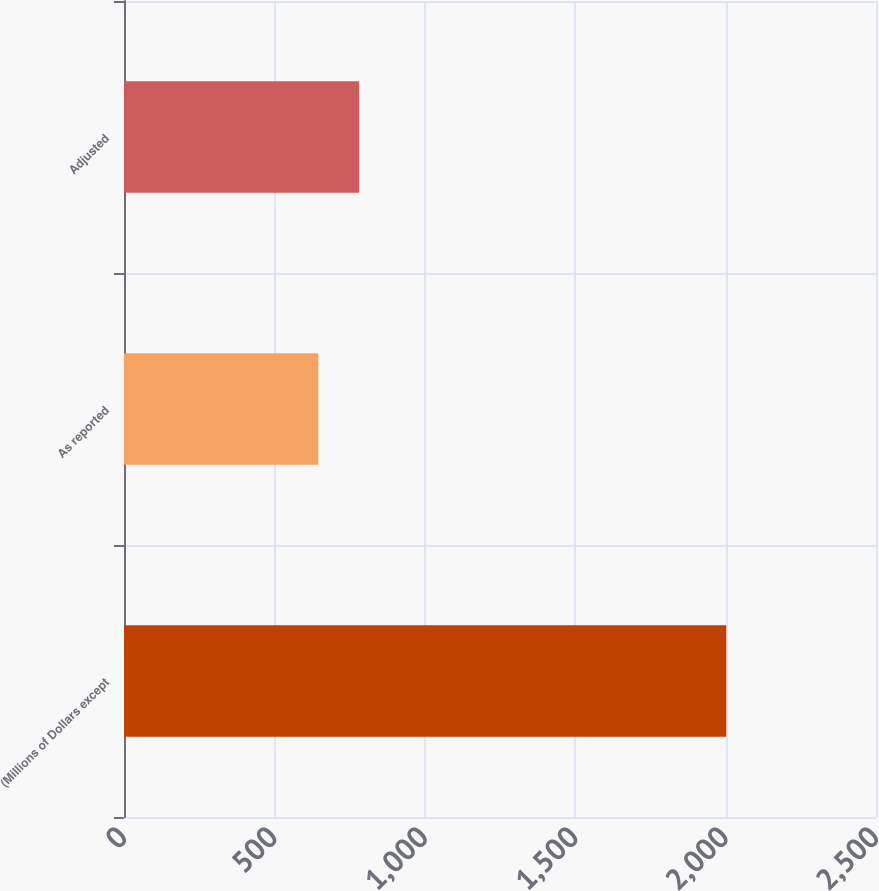Convert chart. <chart><loc_0><loc_0><loc_500><loc_500><bar_chart><fcel>(Millions of Dollars except<fcel>As reported<fcel>Adjusted<nl><fcel>2002<fcel>646<fcel>781.6<nl></chart> 